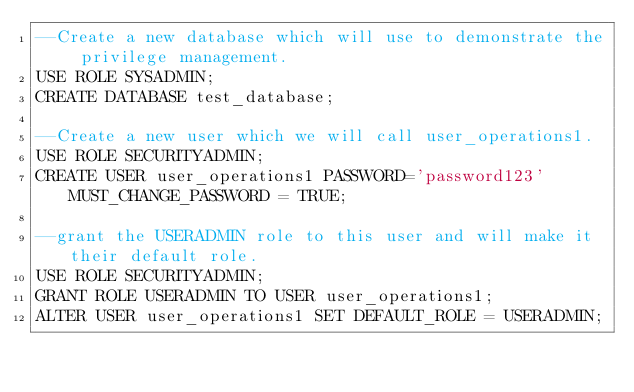<code> <loc_0><loc_0><loc_500><loc_500><_SQL_>--Create a new database which will use to demonstrate the privilege management.
USE ROLE SYSADMIN;
CREATE DATABASE test_database;
 
--Create a new user which we will call user_operations1.
USE ROLE SECURITYADMIN;
CREATE USER user_operations1 PASSWORD='password123' MUST_CHANGE_PASSWORD = TRUE;
 
--grant the USERADMIN role to this user and will make it their default role.
USE ROLE SECURITYADMIN;
GRANT ROLE USERADMIN TO USER user_operations1;
ALTER USER user_operations1 SET DEFAULT_ROLE = USERADMIN;</code> 